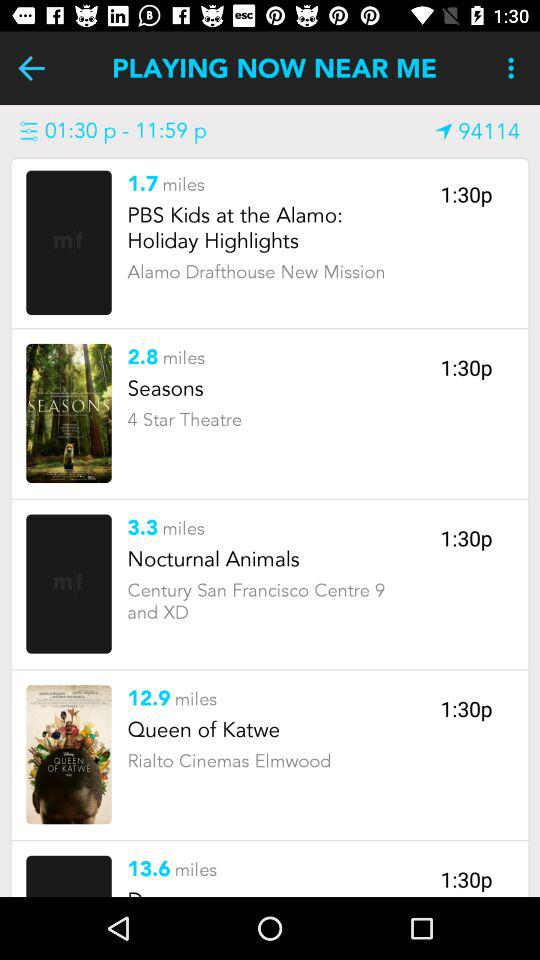How far away is "Seasons" playing? "Seasons" is playing 2.8 miles away. 